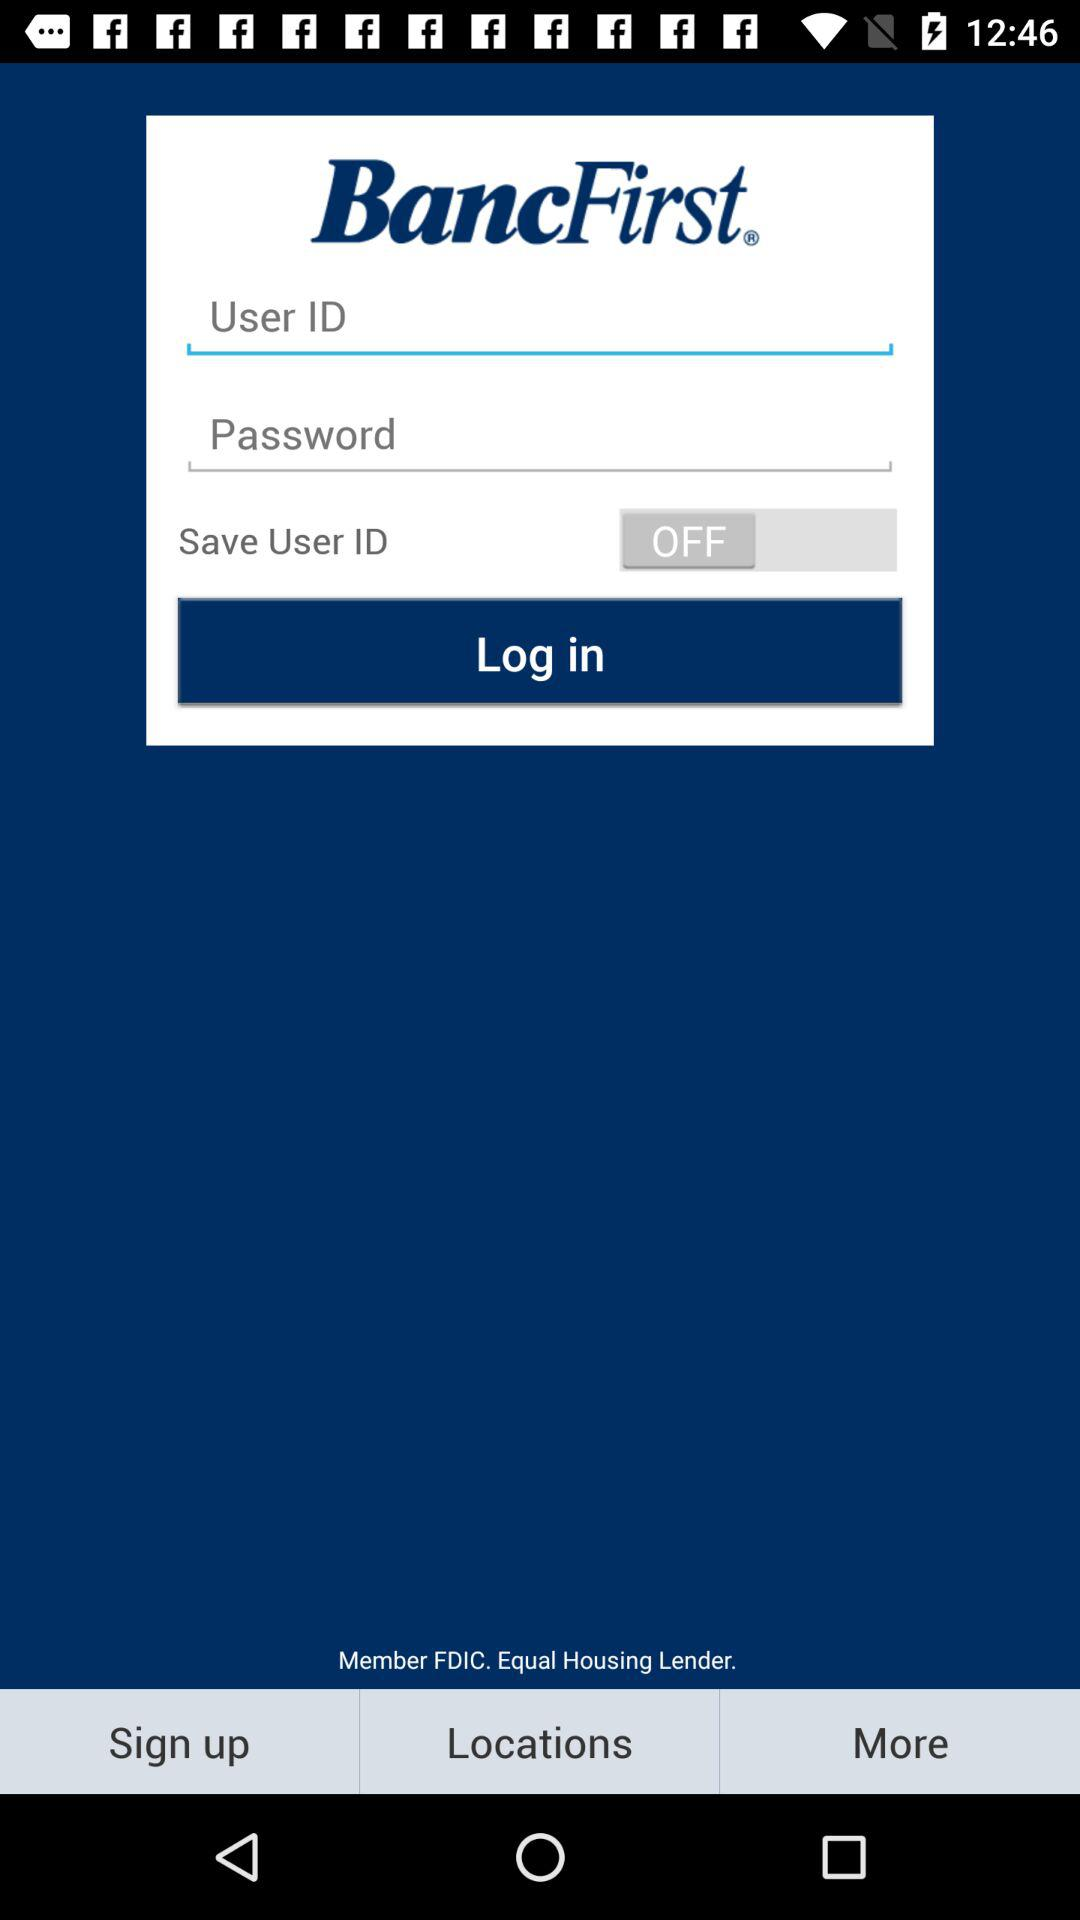How many characters are required to create a password?
When the provided information is insufficient, respond with <no answer>. <no answer> 